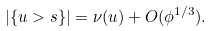<formula> <loc_0><loc_0><loc_500><loc_500>| \{ u > s \} | = \nu ( u ) + O ( \phi ^ { 1 / 3 } ) .</formula> 